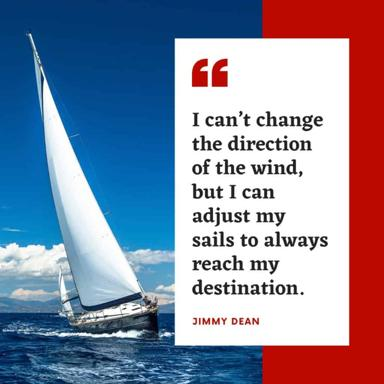Can you describe the visual content of the image? The image displays a vivid portrayal of a sailboat cutting through deep blue waters under clear skies, which visually complements the motivational quote by Jimmy Dean. The red frame bordering the image adds a bold touch, possibly symbolizing passion or urgency. The overall composition blends textual inspiration with nautical imagery to reinforce the theme of navigating through life's challenges. 